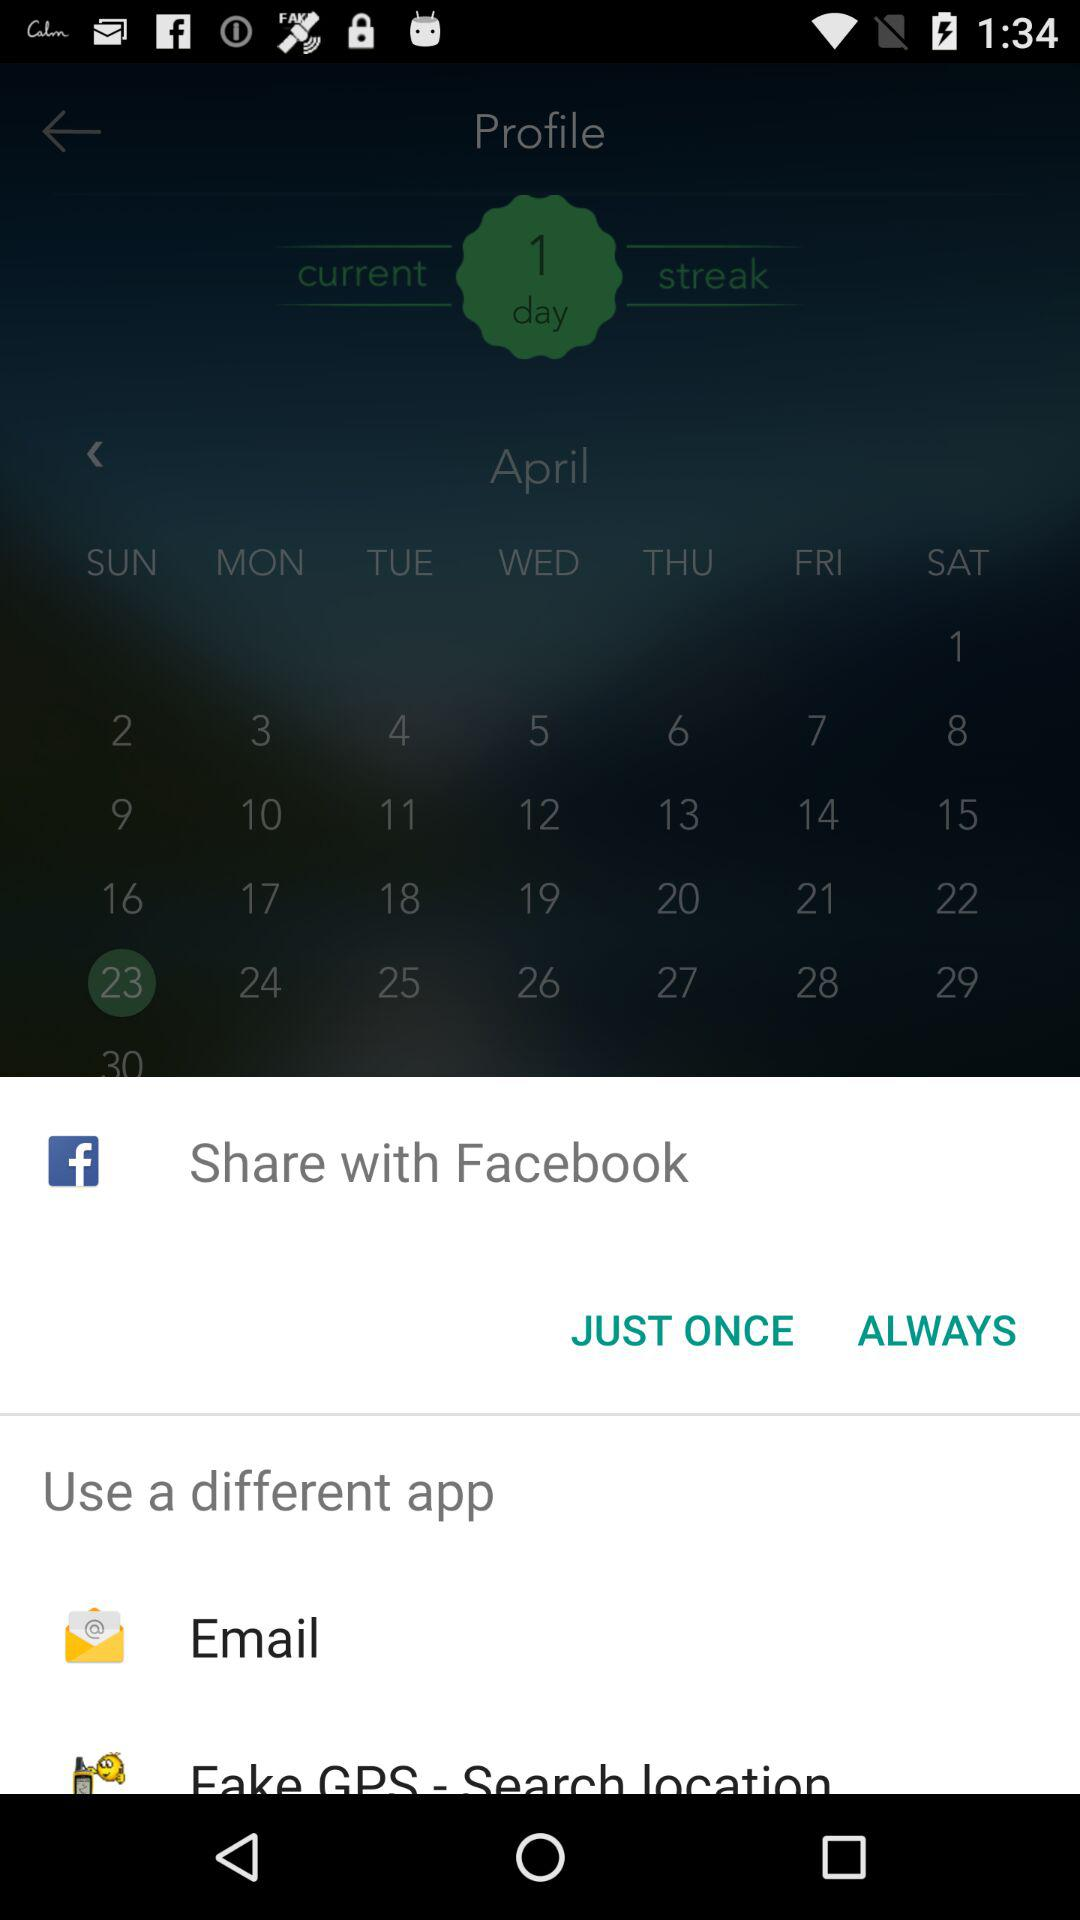What are the different applications through which we can share? The different applications through which we can share are "Email" and "Fake GPS - Search location". 